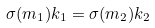Convert formula to latex. <formula><loc_0><loc_0><loc_500><loc_500>\sigma ( m _ { 1 } ) k _ { 1 } = \sigma ( m _ { 2 } ) k _ { 2 }</formula> 